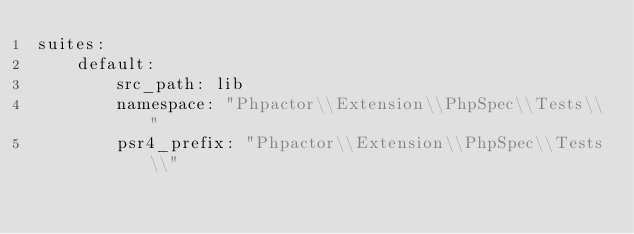<code> <loc_0><loc_0><loc_500><loc_500><_YAML_>suites:
    default:
        src_path: lib
        namespace: "Phpactor\\Extension\\PhpSpec\\Tests\\"
        psr4_prefix: "Phpactor\\Extension\\PhpSpec\\Tests\\"
</code> 